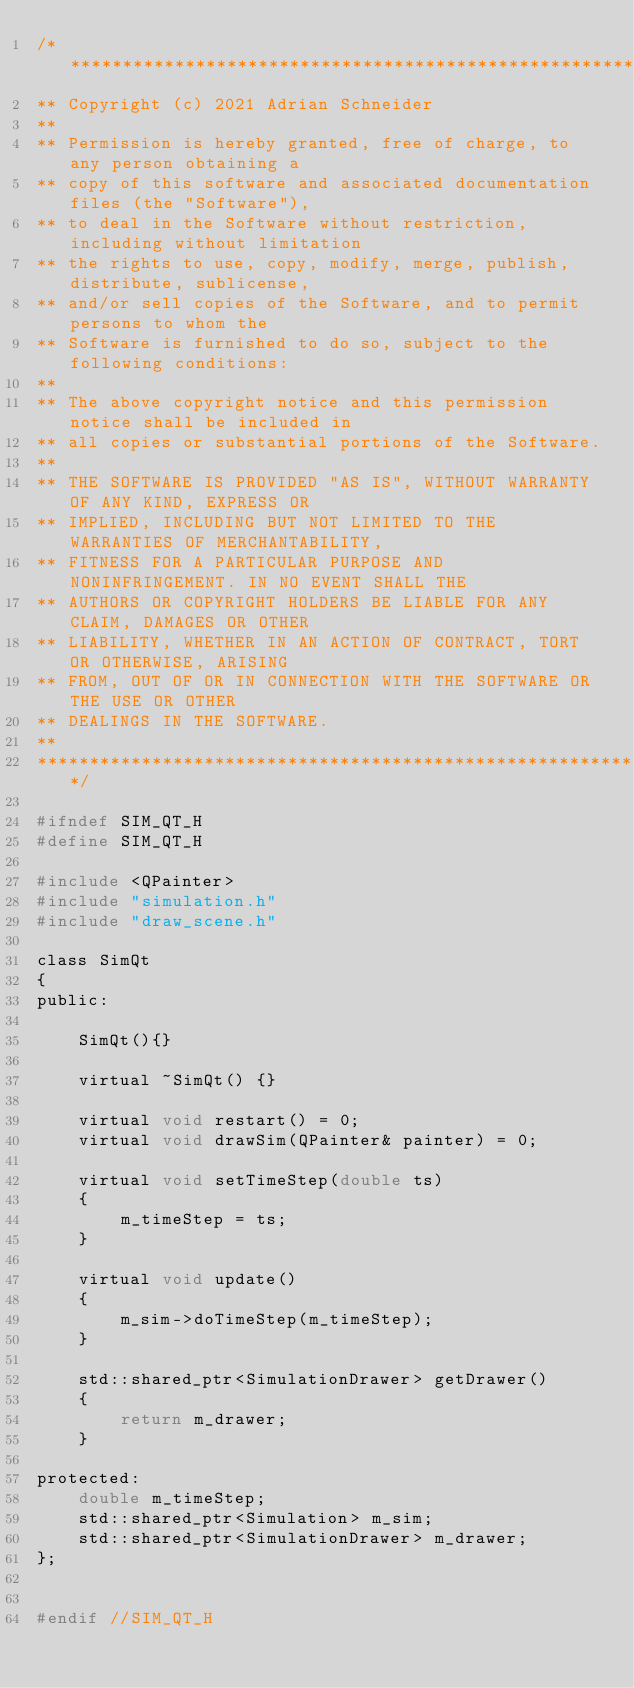Convert code to text. <code><loc_0><loc_0><loc_500><loc_500><_C_>/****************************************************************************
** Copyright (c) 2021 Adrian Schneider
**
** Permission is hereby granted, free of charge, to any person obtaining a
** copy of this software and associated documentation files (the "Software"),
** to deal in the Software without restriction, including without limitation
** the rights to use, copy, modify, merge, publish, distribute, sublicense,
** and/or sell copies of the Software, and to permit persons to whom the
** Software is furnished to do so, subject to the following conditions:
**
** The above copyright notice and this permission notice shall be included in
** all copies or substantial portions of the Software.
**
** THE SOFTWARE IS PROVIDED "AS IS", WITHOUT WARRANTY OF ANY KIND, EXPRESS OR
** IMPLIED, INCLUDING BUT NOT LIMITED TO THE WARRANTIES OF MERCHANTABILITY,
** FITNESS FOR A PARTICULAR PURPOSE AND NONINFRINGEMENT. IN NO EVENT SHALL THE
** AUTHORS OR COPYRIGHT HOLDERS BE LIABLE FOR ANY CLAIM, DAMAGES OR OTHER
** LIABILITY, WHETHER IN AN ACTION OF CONTRACT, TORT OR OTHERWISE, ARISING
** FROM, OUT OF OR IN CONNECTION WITH THE SOFTWARE OR THE USE OR OTHER
** DEALINGS IN THE SOFTWARE.
**
*****************************************************************************/

#ifndef SIM_QT_H
#define SIM_QT_H

#include <QPainter>
#include "simulation.h"
#include "draw_scene.h"

class SimQt
{
public:

    SimQt(){}

    virtual ~SimQt() {}

    virtual void restart() = 0;
    virtual void drawSim(QPainter& painter) = 0;

    virtual void setTimeStep(double ts)
    {
        m_timeStep = ts;
    }

    virtual void update()
    {
        m_sim->doTimeStep(m_timeStep);
    }

    std::shared_ptr<SimulationDrawer> getDrawer()
    {
        return m_drawer;
    }

protected:
    double m_timeStep;
    std::shared_ptr<Simulation> m_sim;
    std::shared_ptr<SimulationDrawer> m_drawer;
};


#endif //SIM_QT_H
</code> 